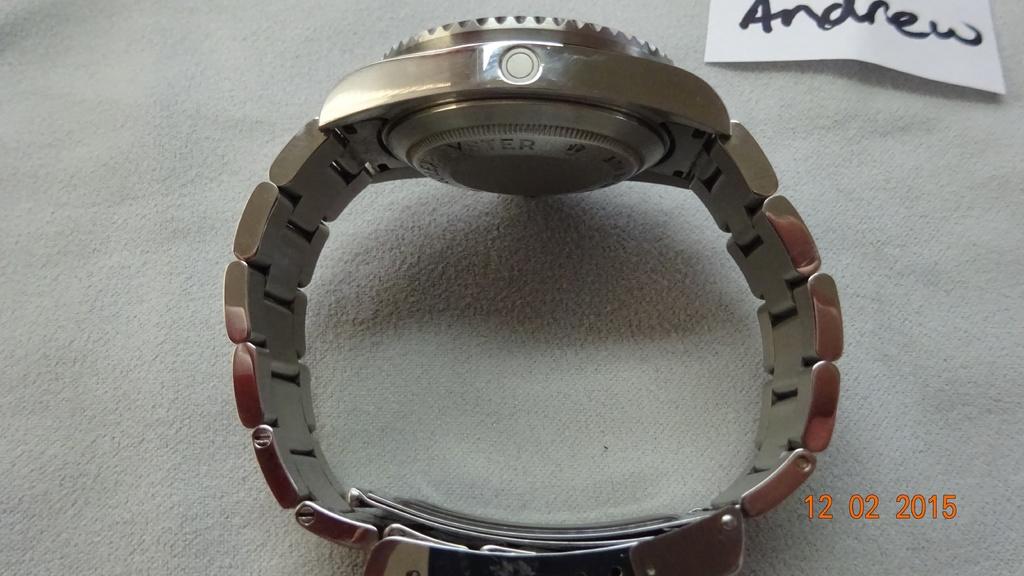Whose watch is this?
Make the answer very short. Andrew. What is the date?
Provide a short and direct response. 12 02 2015. 